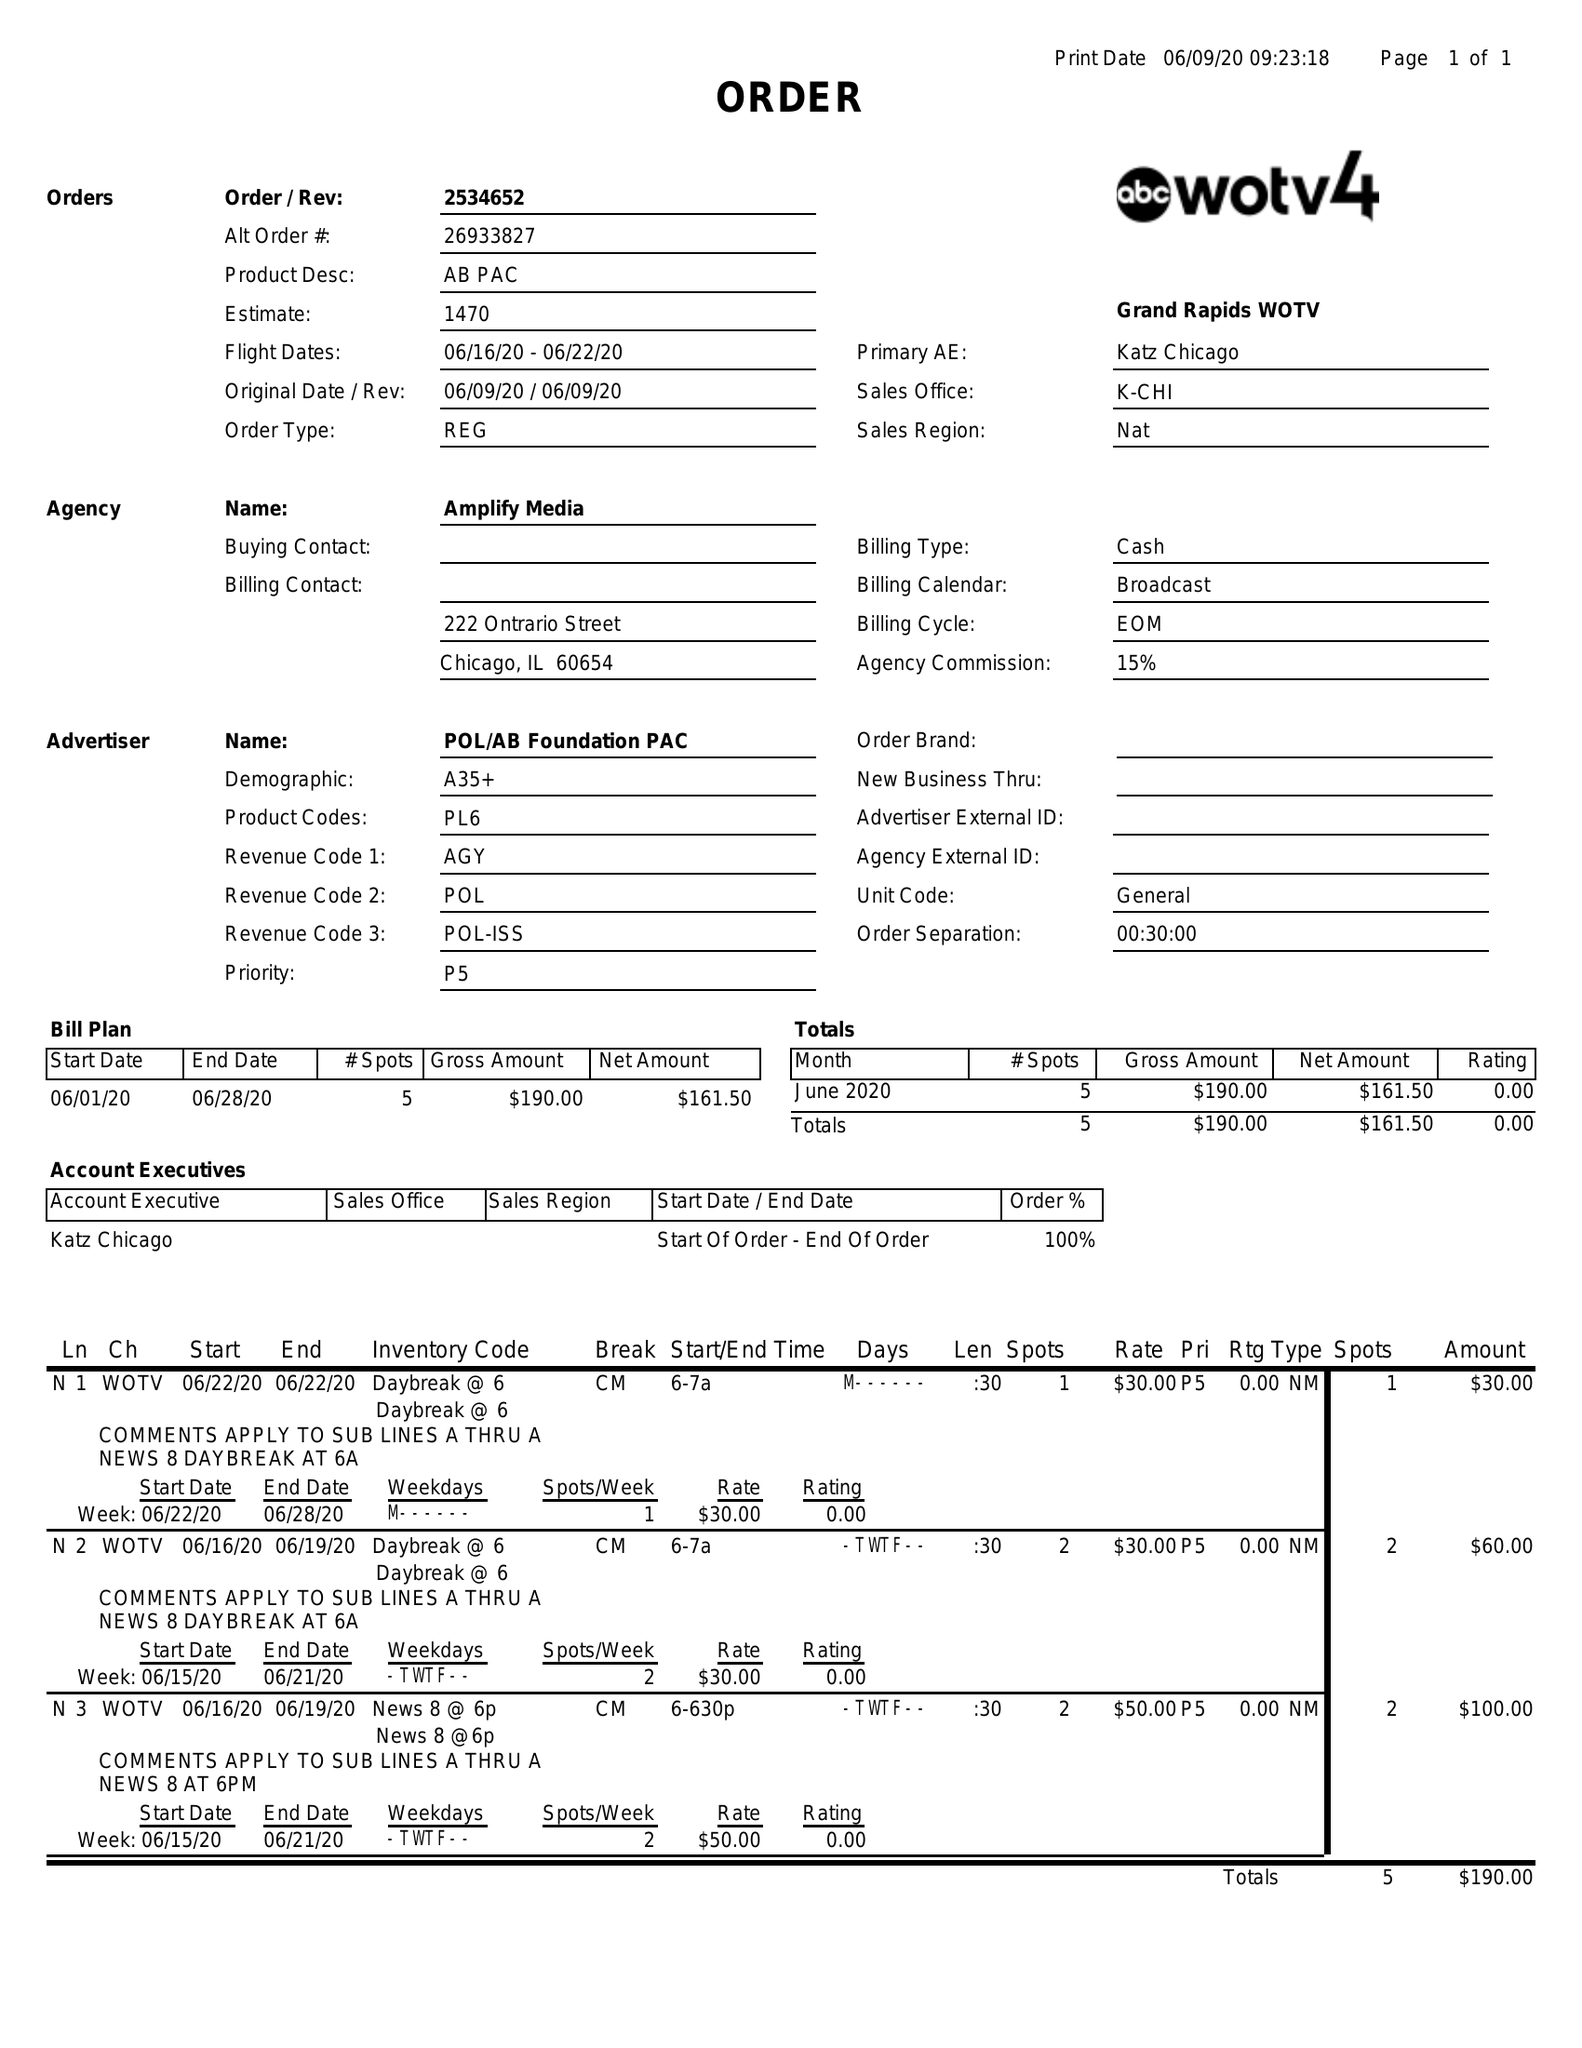What is the value for the contract_num?
Answer the question using a single word or phrase. 2534652 